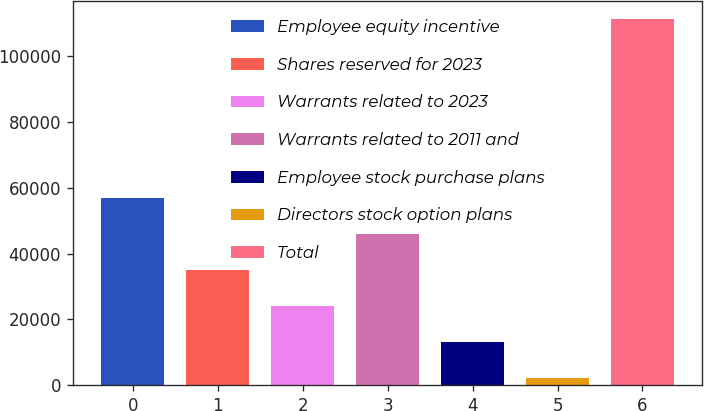<chart> <loc_0><loc_0><loc_500><loc_500><bar_chart><fcel>Employee equity incentive<fcel>Shares reserved for 2023<fcel>Warrants related to 2023<fcel>Warrants related to 2011 and<fcel>Employee stock purchase plans<fcel>Directors stock option plans<fcel>Total<nl><fcel>56776.5<fcel>34988.3<fcel>24094.2<fcel>45882.4<fcel>13200.1<fcel>2306<fcel>111247<nl></chart> 